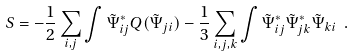<formula> <loc_0><loc_0><loc_500><loc_500>S = - \frac { 1 } { 2 } \sum _ { i , j } \int \tilde { \Psi } _ { i j } ^ { * } Q ( \tilde { \Psi } _ { j i } ) - \frac { 1 } { 3 } \sum _ { i , j , k } \int \tilde { \Psi } _ { i j } ^ { * } \tilde { \Psi } _ { j k } ^ { * } \tilde { \Psi } _ { k i } \ .</formula> 